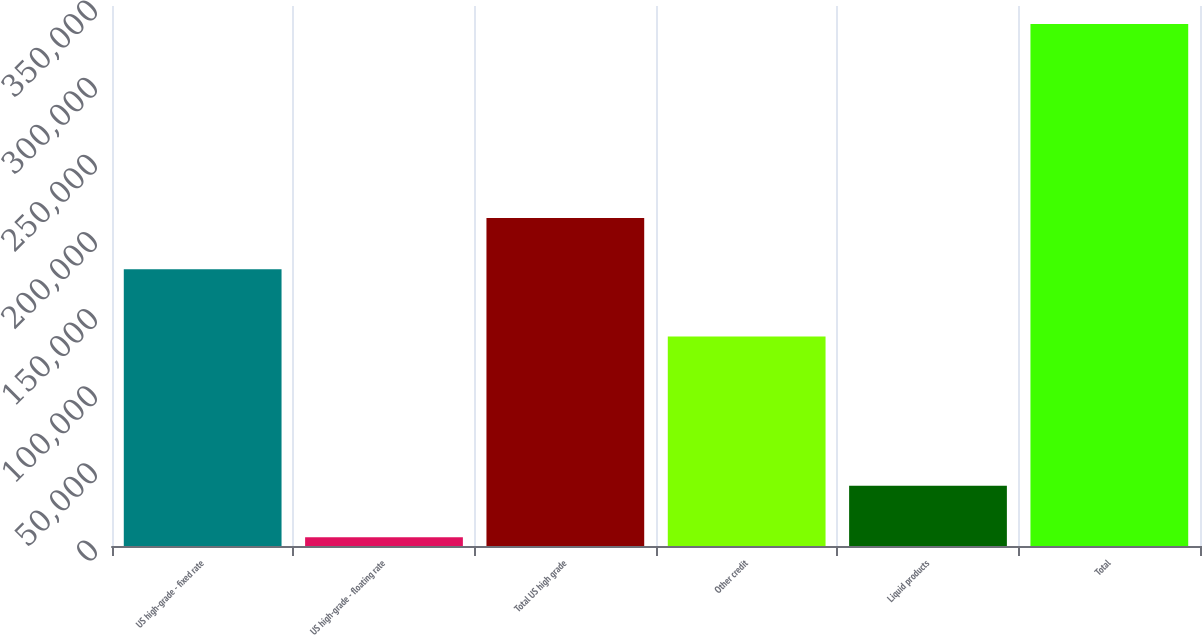Convert chart to OTSL. <chart><loc_0><loc_0><loc_500><loc_500><bar_chart><fcel>US high-grade - fixed rate<fcel>US high-grade - floating rate<fcel>Total US high grade<fcel>Other credit<fcel>Liquid products<fcel>Total<nl><fcel>179317<fcel>5749<fcel>212568<fcel>135799<fcel>38999.9<fcel>338258<nl></chart> 